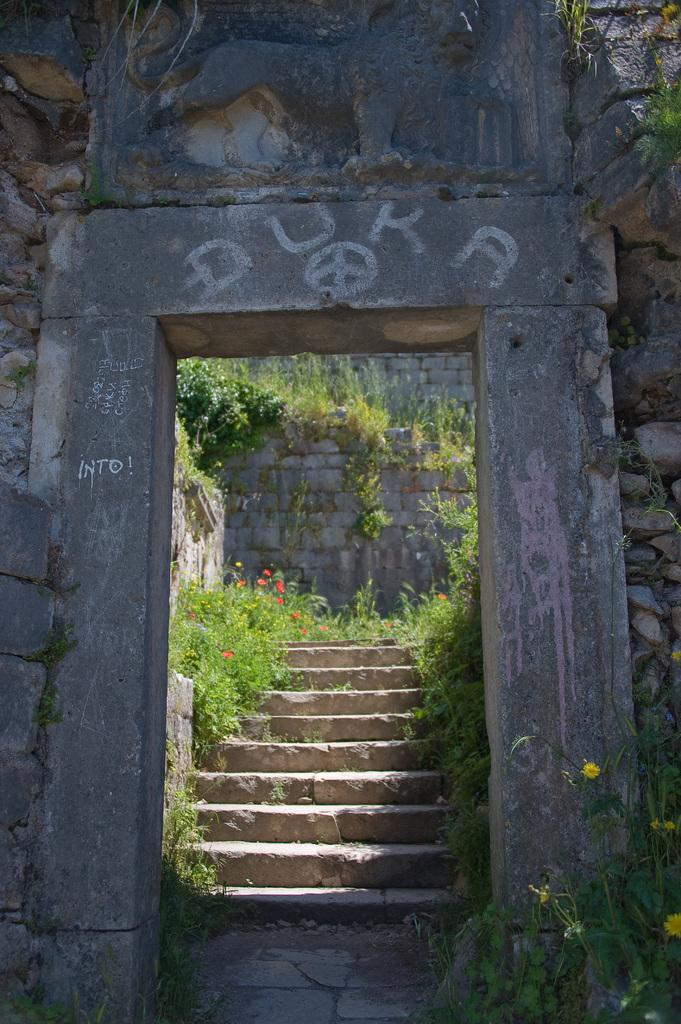What type of structure can be seen in the image? There is an arch in the image. What architectural feature is present in the image? There are stairs in the image. What type of vegetation is present in the image? There are flowers on both sides of the image, and they are associated with plants. What can be seen in the background of the image? There is a wall visible in the background of the image. What day of the week is depicted in the image? There is no specific day of the week depicted in the image. What discovery was made by the flowers in the image? There is no indication of a discovery made by the flowers in the image. 